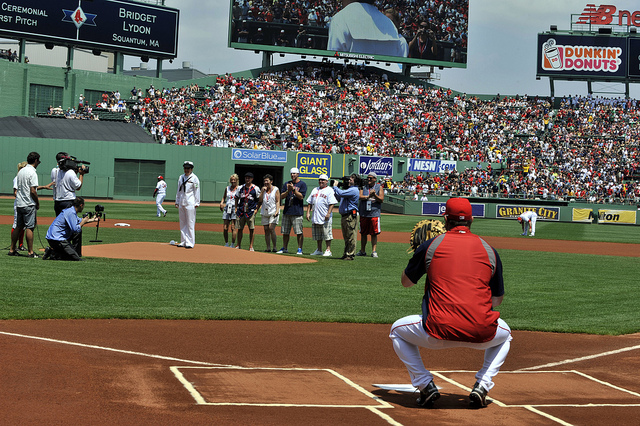Identify the text displayed in this image. GIANT GLASS NESN BRIDGET LYDON DONUTS DUNKIN CITY ST CAREMONISAL 